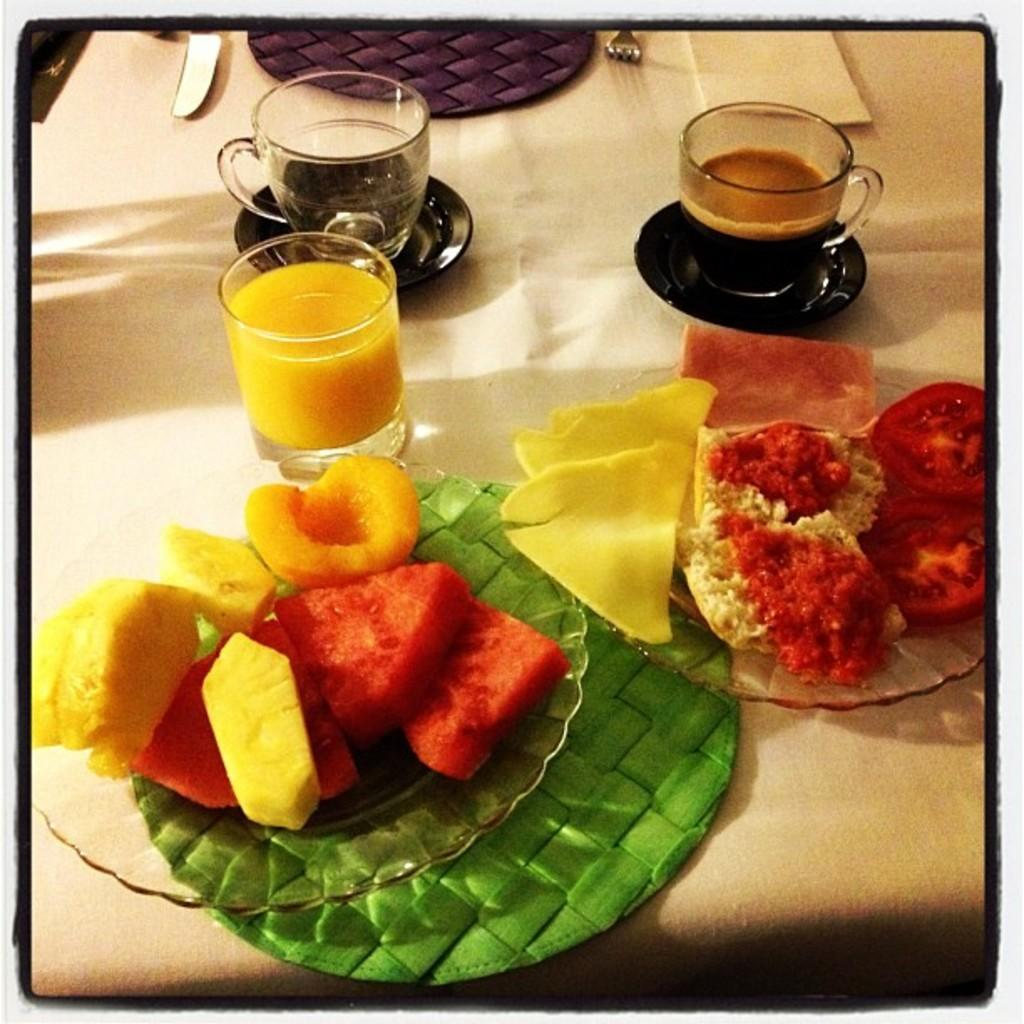What type of furniture is visible in the image? There is a table in the image. What is on the table? There are food items in a bowl, a glass with a liquid, cups, spoons, and knives on the table. What is the soccer ball used for? The soccer ball is used for playing soccer. What type of base is supporting the soccer ball in the image? There is no base supporting the soccer ball in the image; it is likely on the ground or another surface. What is the curve of the soccer ball in the image? The image does not provide enough detail to determine the curve of the soccer ball. 